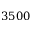Convert formula to latex. <formula><loc_0><loc_0><loc_500><loc_500>3 5 0 0</formula> 